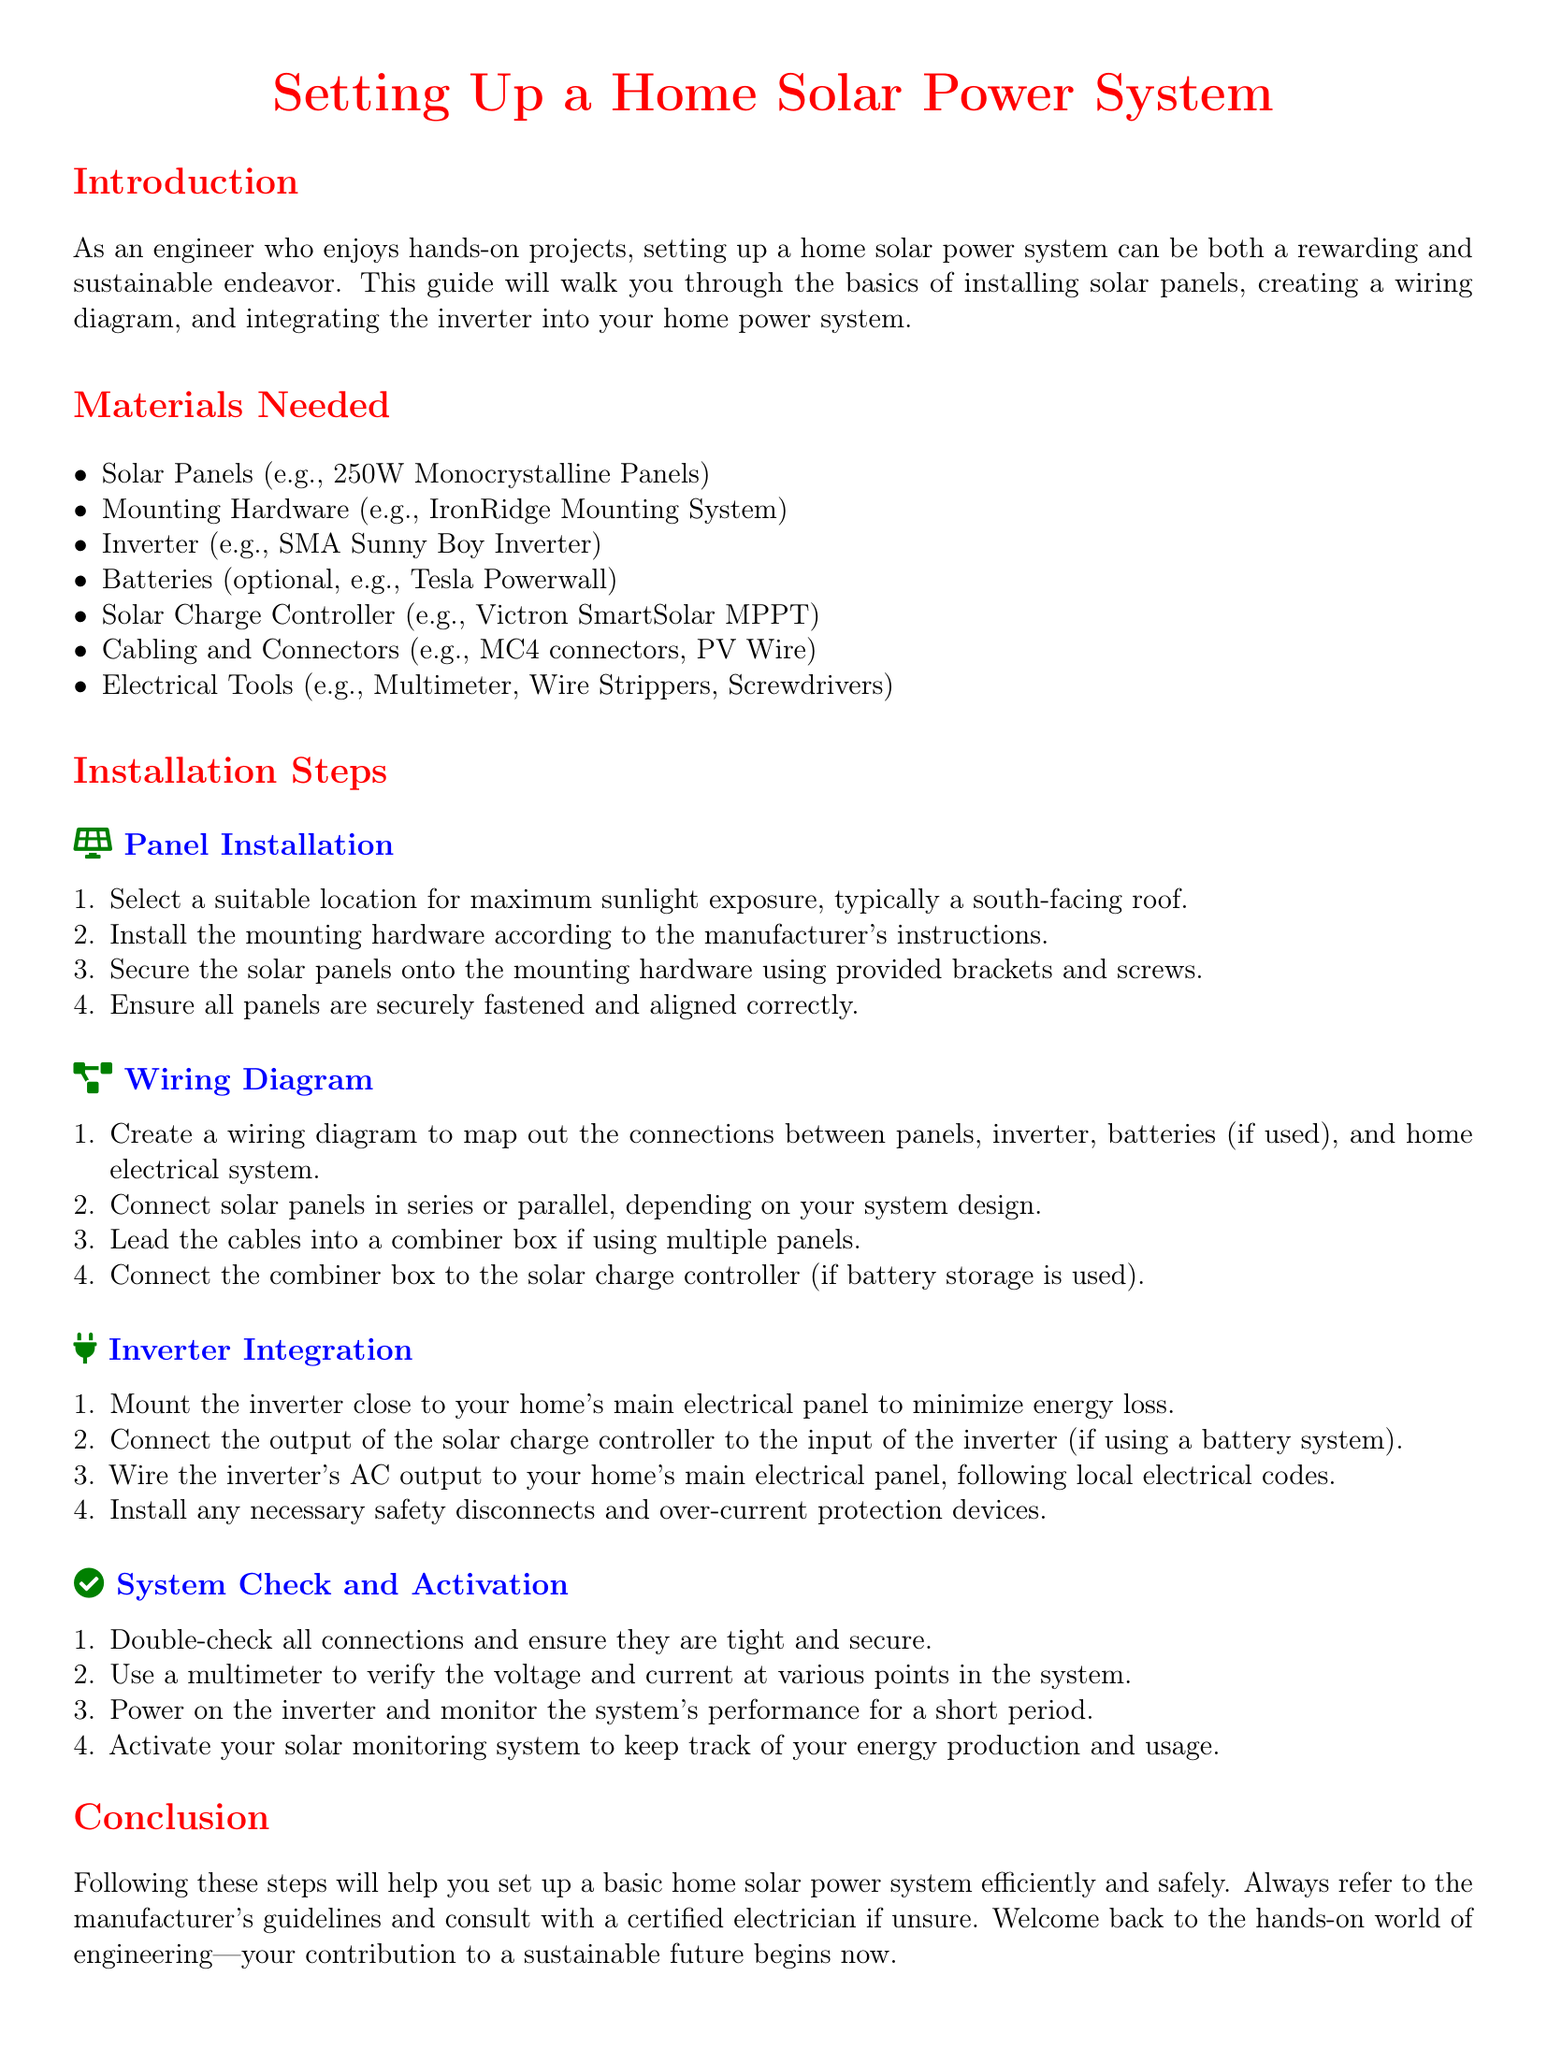what is the first material listed? The first material in the list of needed materials is Solar Panels.
Answer: Solar Panels how many installation steps are there? The document lists a total of four main installation steps.
Answer: four what type of inverter is mentioned? The document specifies the SMA Sunny Boy Inverter as an example.
Answer: SMA Sunny Boy Inverter where should the solar panels be installed for maximum exposure? The instruction states that the panels should be installed on a south-facing roof for maximum sunlight exposure.
Answer: south-facing roof what is the purpose of the multimeter in the system check? The multimeter is used to verify the voltage and current at various points in the system.
Answer: verify voltage and current what optional component can be included for energy storage? The document lists the Tesla Powerwall as an optional component for energy storage.
Answer: Tesla Powerwall what is the last step in the system check? The last step in the system check is to activate the solar monitoring system.
Answer: activate the solar monitoring system how should the inverter be mounted? The inverter should be mounted close to your home's main electrical panel to minimize energy loss.
Answer: close to the main electrical panel 